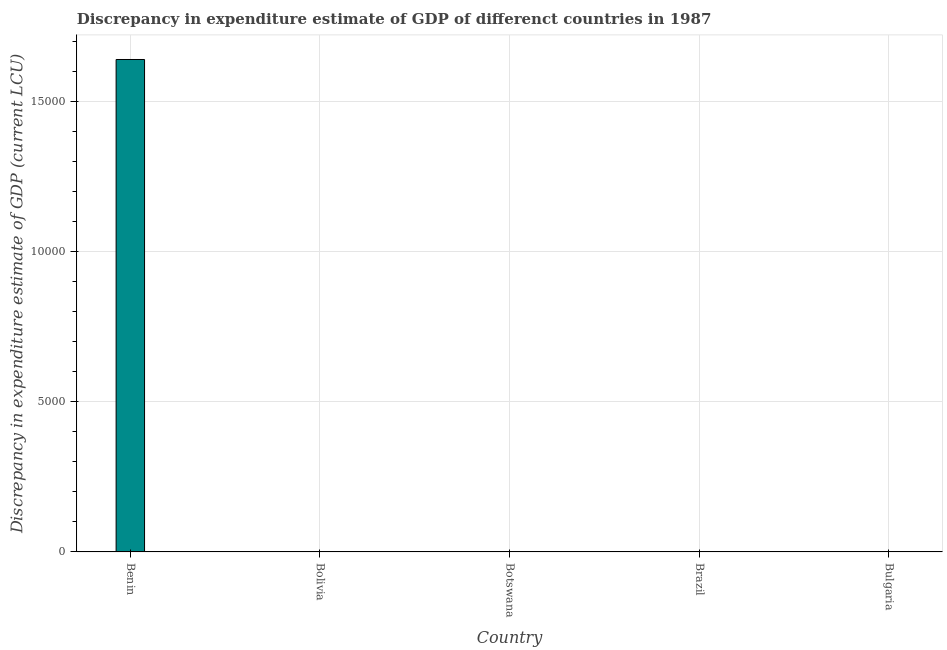What is the title of the graph?
Provide a short and direct response. Discrepancy in expenditure estimate of GDP of differenct countries in 1987. What is the label or title of the X-axis?
Ensure brevity in your answer.  Country. What is the label or title of the Y-axis?
Provide a succinct answer. Discrepancy in expenditure estimate of GDP (current LCU). What is the discrepancy in expenditure estimate of gdp in Bulgaria?
Your answer should be very brief. 0. Across all countries, what is the maximum discrepancy in expenditure estimate of gdp?
Ensure brevity in your answer.  1.64e+04. In which country was the discrepancy in expenditure estimate of gdp maximum?
Your answer should be very brief. Benin. What is the sum of the discrepancy in expenditure estimate of gdp?
Your response must be concise. 1.64e+04. What is the difference between the discrepancy in expenditure estimate of gdp in Benin and Bolivia?
Make the answer very short. 1.64e+04. What is the average discrepancy in expenditure estimate of gdp per country?
Provide a succinct answer. 3280. What is the difference between the highest and the lowest discrepancy in expenditure estimate of gdp?
Offer a terse response. 1.64e+04. How many bars are there?
Provide a short and direct response. 2. Are all the bars in the graph horizontal?
Make the answer very short. No. What is the difference between two consecutive major ticks on the Y-axis?
Give a very brief answer. 5000. Are the values on the major ticks of Y-axis written in scientific E-notation?
Give a very brief answer. No. What is the Discrepancy in expenditure estimate of GDP (current LCU) of Benin?
Provide a succinct answer. 1.64e+04. What is the Discrepancy in expenditure estimate of GDP (current LCU) of Bolivia?
Offer a terse response. 8e-7. What is the Discrepancy in expenditure estimate of GDP (current LCU) of Botswana?
Your answer should be very brief. 0. What is the Discrepancy in expenditure estimate of GDP (current LCU) of Brazil?
Give a very brief answer. 0. What is the Discrepancy in expenditure estimate of GDP (current LCU) in Bulgaria?
Your answer should be very brief. 0. What is the difference between the Discrepancy in expenditure estimate of GDP (current LCU) in Benin and Bolivia?
Make the answer very short. 1.64e+04. What is the ratio of the Discrepancy in expenditure estimate of GDP (current LCU) in Benin to that in Bolivia?
Offer a terse response. 2.05e+1. 